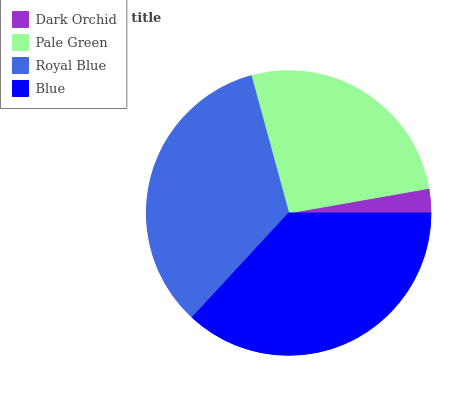Is Dark Orchid the minimum?
Answer yes or no. Yes. Is Blue the maximum?
Answer yes or no. Yes. Is Pale Green the minimum?
Answer yes or no. No. Is Pale Green the maximum?
Answer yes or no. No. Is Pale Green greater than Dark Orchid?
Answer yes or no. Yes. Is Dark Orchid less than Pale Green?
Answer yes or no. Yes. Is Dark Orchid greater than Pale Green?
Answer yes or no. No. Is Pale Green less than Dark Orchid?
Answer yes or no. No. Is Royal Blue the high median?
Answer yes or no. Yes. Is Pale Green the low median?
Answer yes or no. Yes. Is Blue the high median?
Answer yes or no. No. Is Dark Orchid the low median?
Answer yes or no. No. 